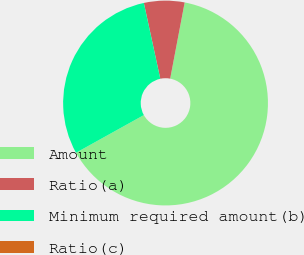Convert chart to OTSL. <chart><loc_0><loc_0><loc_500><loc_500><pie_chart><fcel>Amount<fcel>Ratio(a)<fcel>Minimum required amount(b)<fcel>Ratio(c)<nl><fcel>63.94%<fcel>6.39%<fcel>29.67%<fcel>0.0%<nl></chart> 